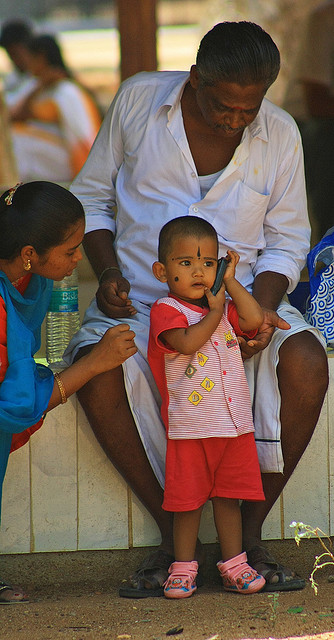What can you infer about the setting of this image? The image seems to be taken outdoors, possibly at a community gathering or market place, given the presence of other individuals in the background. The attire of the individuals, which includes bright colors and lightweight clothing, and the structure in the background, suggest a warm, tropical climate. It speaks to a communal way of life where social interactions are a part of daily life. 